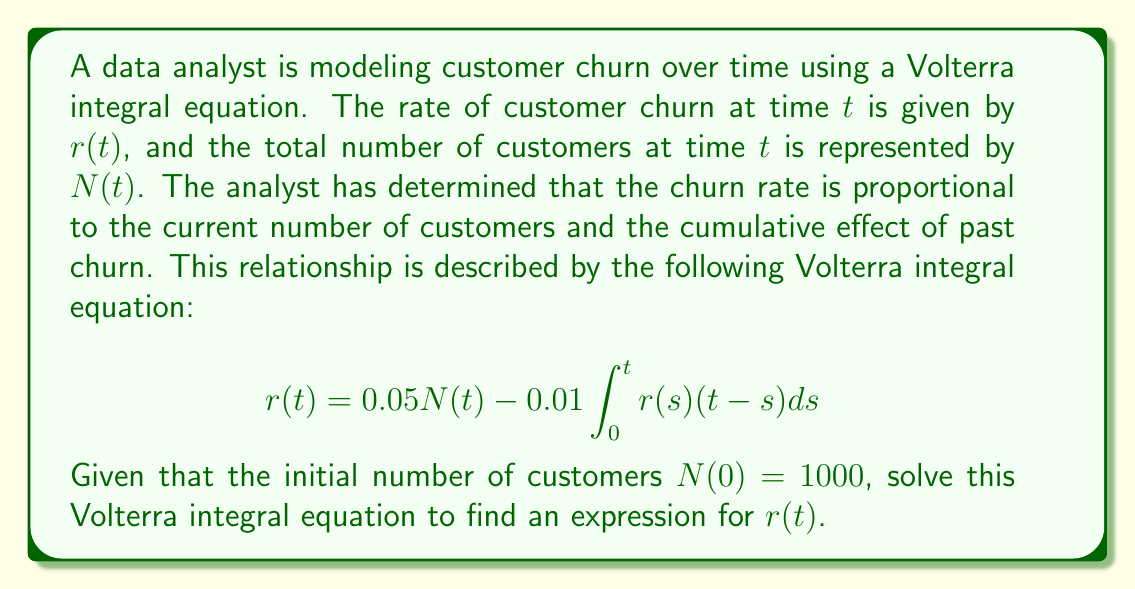Could you help me with this problem? To solve this Volterra integral equation, we'll follow these steps:

1) First, we need to recognize that this is a linear Volterra integral equation of the second kind. The general form is:

   $$r(t) = f(t) + \lambda\int_0^t K(t,s)r(s)ds$$

   where in our case, $f(t) = 0.05N(t)$, $\lambda = -0.01$, and $K(t,s) = t-s$.

2) For linear Volterra equations, we can use the method of successive approximations (Picard iteration). We start with an initial guess $r_0(t)$ and then iteratively improve our approximation:

   $$r_{n+1}(t) = f(t) + \lambda\int_0^t K(t,s)r_n(s)ds$$

3) Let's start with $r_0(t) = f(t) = 0.05N(t)$. We know $N(0) = 1000$, but we don't know $N(t)$ for $t > 0$. However, we can approximate it as constant for small $t$: $N(t) \approx 1000$.

4) Now, let's compute the first iteration:

   $$\begin{align*}
   r_1(t) &= 0.05N(t) - 0.01\int_0^t (t-s)(0.05N(s))ds \\
   &\approx 50 - 0.01\int_0^t (t-s)(50)ds \\
   &= 50 - 0.5\int_0^t (t-s)ds \\
   &= 50 - 0.5[ts - \frac{s^2}{2}]_0^t \\
   &= 50 - 0.5(t^2 - \frac{t^2}{2}) \\
   &= 50 - 0.25t^2
   \end{align*}$$

5) This gives us an approximate solution. For a more accurate solution, we would continue this process, but each iteration becomes increasingly complex. The exact solution would be the limit of these iterations as $n$ approaches infinity.

6) We can interpret this result: The churn rate starts at 50 (5% of 1000) and decreases quadratically over time, likely due to the cumulative effect of past churn reducing the customer base.
Answer: $r(t) \approx 50 - 0.25t^2$ 